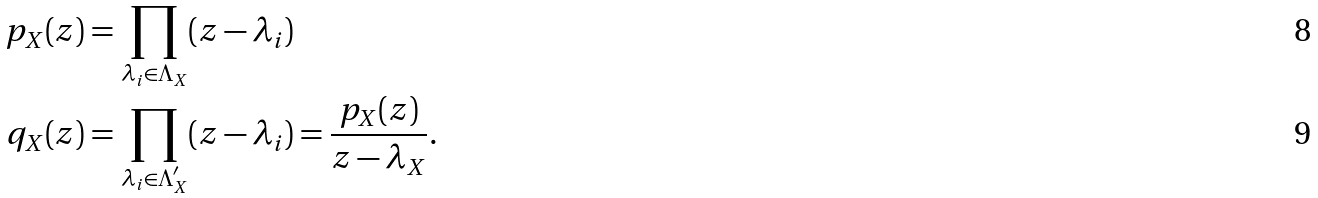<formula> <loc_0><loc_0><loc_500><loc_500>p _ { X } ( z ) & = \prod _ { \lambda _ { i } \in \Lambda _ { X } } ( z - \lambda _ { i } ) \\ q _ { X } ( z ) & = \prod _ { \lambda _ { i } \in \Lambda _ { X } ^ { \prime } } ( z - \lambda _ { i } ) = \frac { p _ { X } ( z ) } { z - \lambda _ { X } } .</formula> 